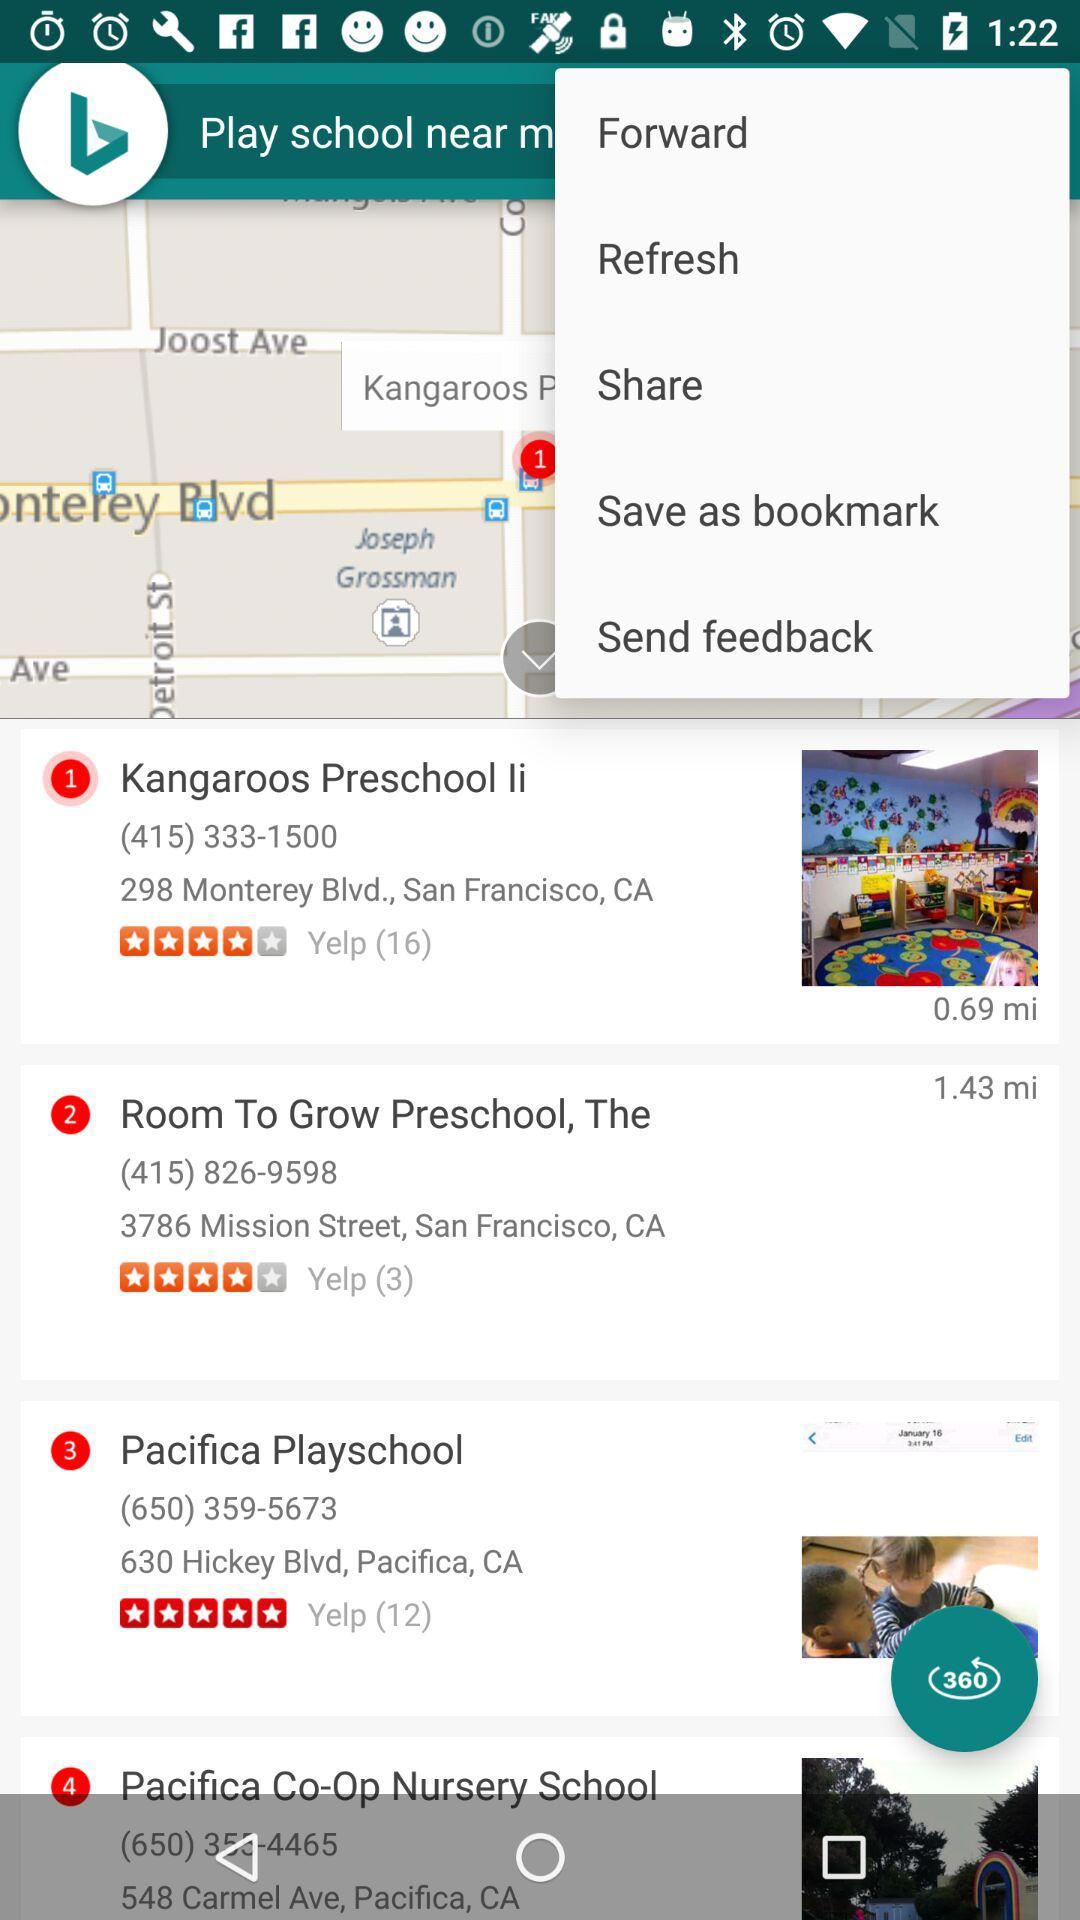What is the rating of "Pacifica Playschool"? The rating of "Pacifica Playschool" is 5 stars. 